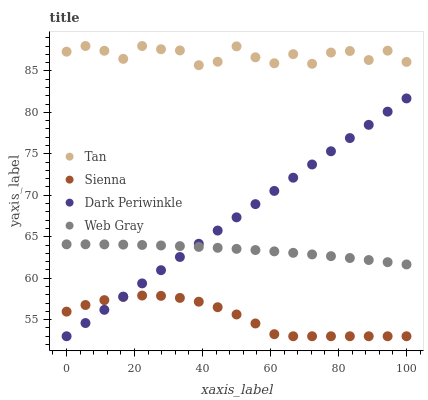Does Sienna have the minimum area under the curve?
Answer yes or no. Yes. Does Tan have the maximum area under the curve?
Answer yes or no. Yes. Does Web Gray have the minimum area under the curve?
Answer yes or no. No. Does Web Gray have the maximum area under the curve?
Answer yes or no. No. Is Dark Periwinkle the smoothest?
Answer yes or no. Yes. Is Tan the roughest?
Answer yes or no. Yes. Is Web Gray the smoothest?
Answer yes or no. No. Is Web Gray the roughest?
Answer yes or no. No. Does Sienna have the lowest value?
Answer yes or no. Yes. Does Web Gray have the lowest value?
Answer yes or no. No. Does Tan have the highest value?
Answer yes or no. Yes. Does Web Gray have the highest value?
Answer yes or no. No. Is Dark Periwinkle less than Tan?
Answer yes or no. Yes. Is Tan greater than Dark Periwinkle?
Answer yes or no. Yes. Does Dark Periwinkle intersect Web Gray?
Answer yes or no. Yes. Is Dark Periwinkle less than Web Gray?
Answer yes or no. No. Is Dark Periwinkle greater than Web Gray?
Answer yes or no. No. Does Dark Periwinkle intersect Tan?
Answer yes or no. No. 